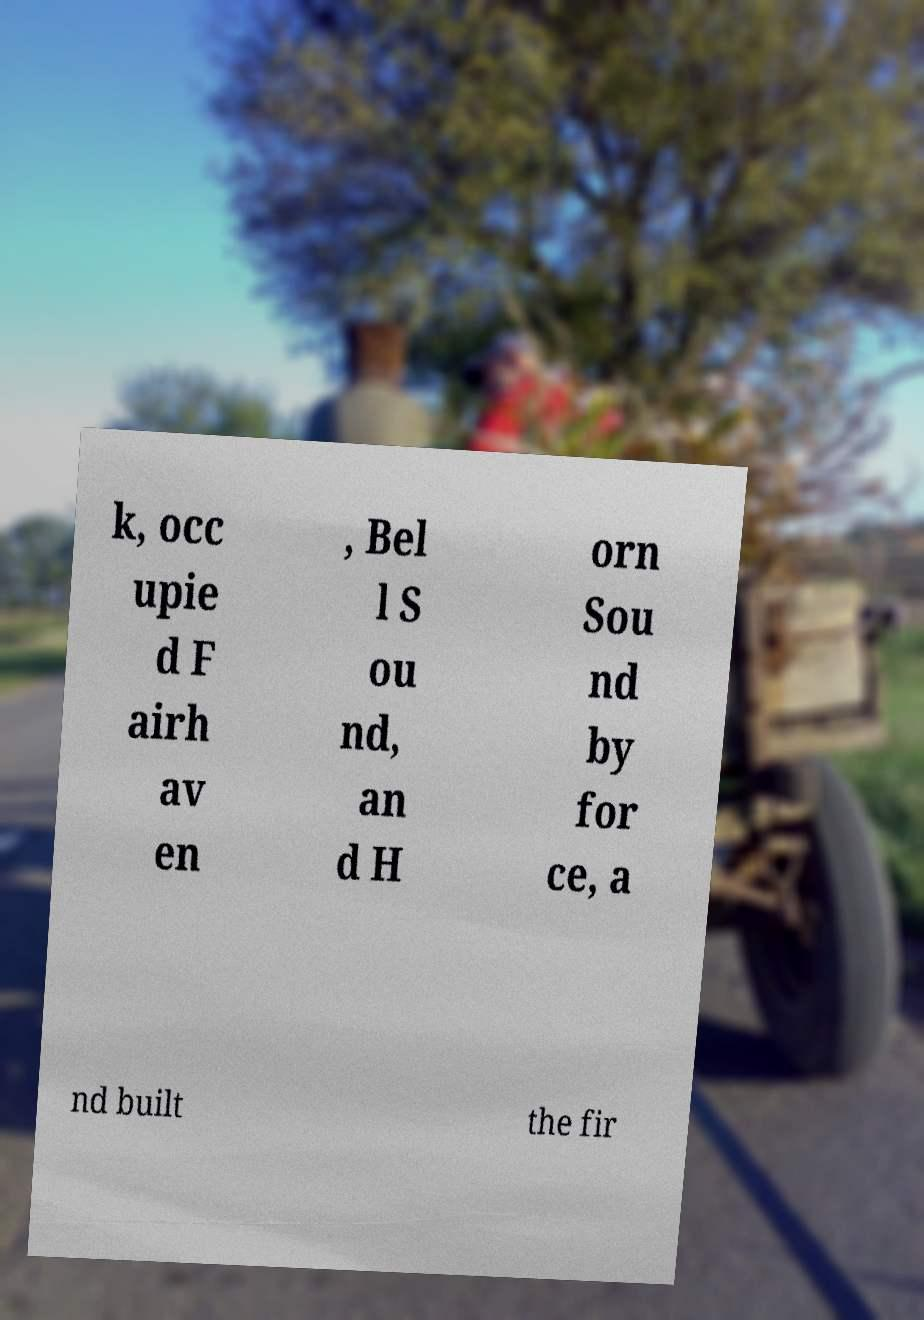I need the written content from this picture converted into text. Can you do that? k, occ upie d F airh av en , Bel l S ou nd, an d H orn Sou nd by for ce, a nd built the fir 